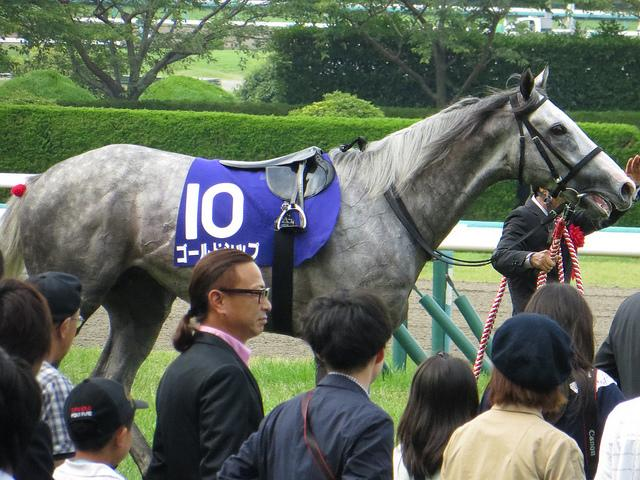What does the number ten indicate? Please explain your reasoning. starting position. The number 10 indicates the starting position of the horse. 